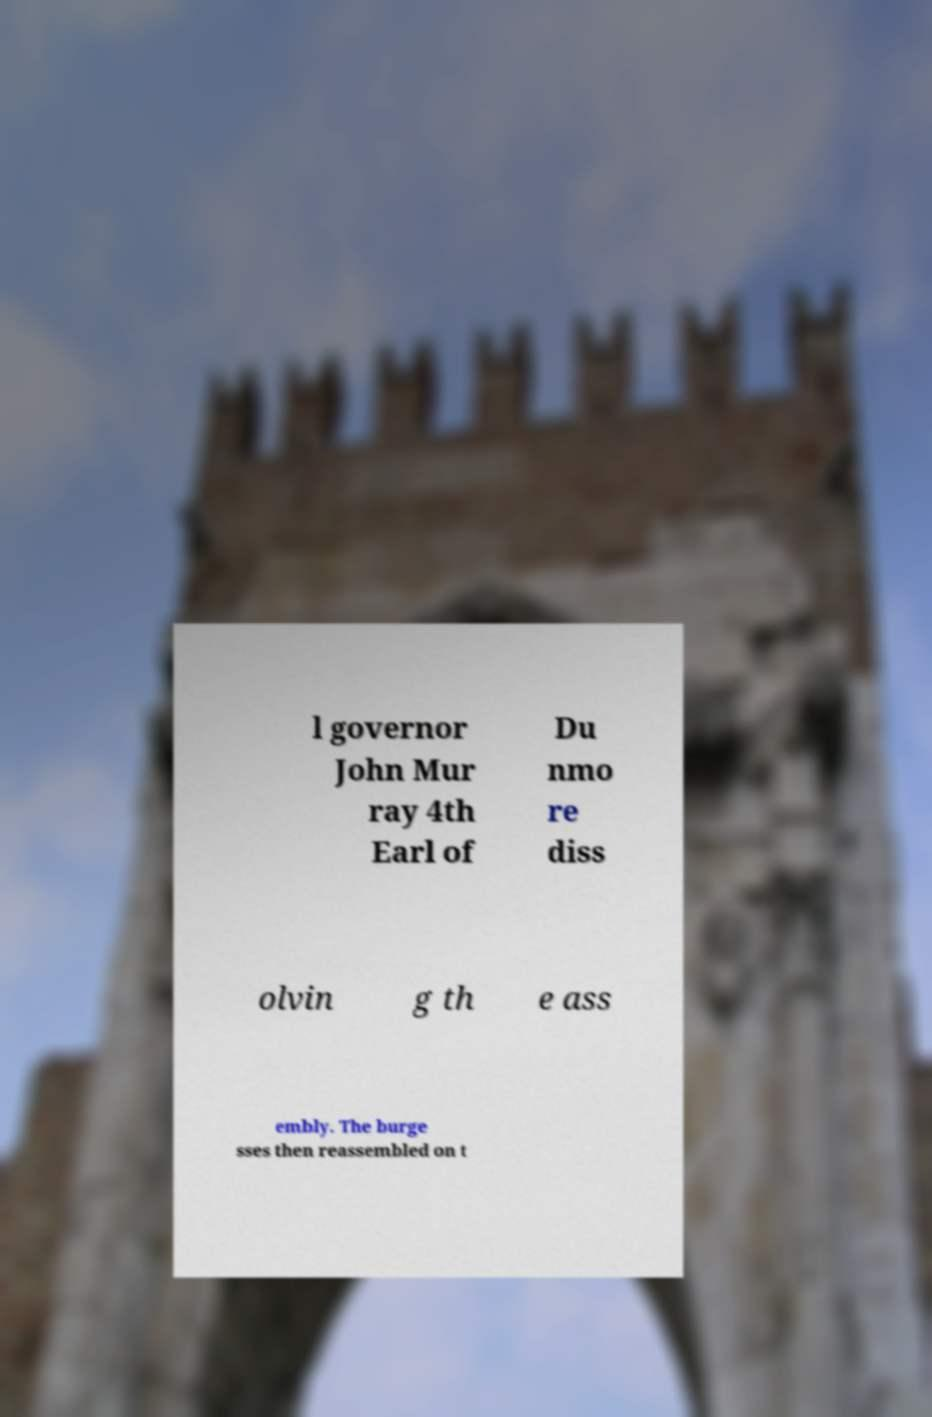I need the written content from this picture converted into text. Can you do that? l governor John Mur ray 4th Earl of Du nmo re diss olvin g th e ass embly. The burge sses then reassembled on t 